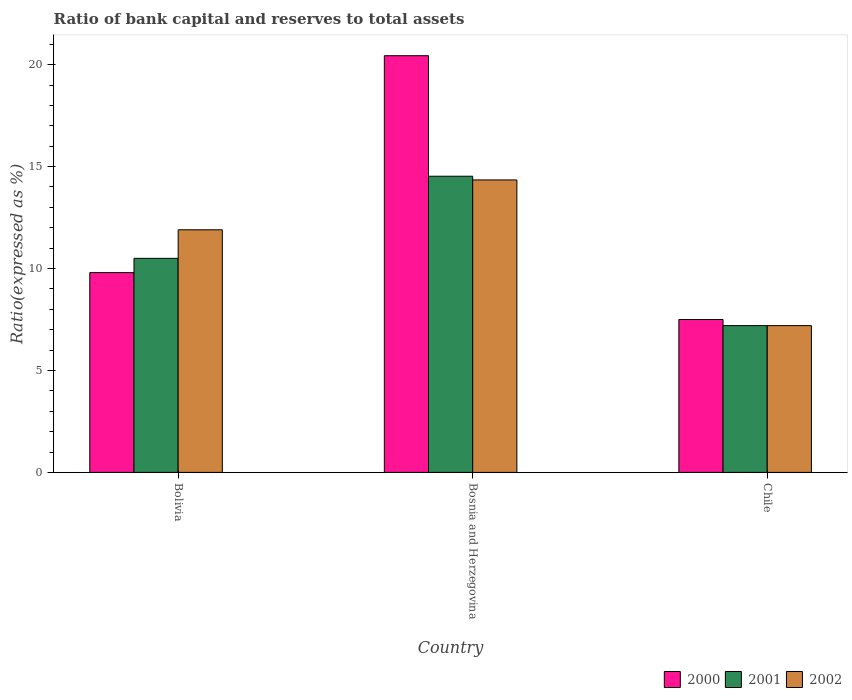How many different coloured bars are there?
Provide a succinct answer. 3. Are the number of bars on each tick of the X-axis equal?
Your answer should be compact. Yes. How many bars are there on the 3rd tick from the right?
Offer a very short reply. 3. What is the label of the 3rd group of bars from the left?
Your answer should be very brief. Chile. In how many cases, is the number of bars for a given country not equal to the number of legend labels?
Ensure brevity in your answer.  0. What is the ratio of bank capital and reserves to total assets in 2000 in Chile?
Your response must be concise. 7.5. Across all countries, what is the maximum ratio of bank capital and reserves to total assets in 2002?
Your answer should be compact. 14.35. Across all countries, what is the minimum ratio of bank capital and reserves to total assets in 2001?
Your answer should be very brief. 7.2. In which country was the ratio of bank capital and reserves to total assets in 2001 maximum?
Your answer should be compact. Bosnia and Herzegovina. What is the total ratio of bank capital and reserves to total assets in 2001 in the graph?
Ensure brevity in your answer.  32.23. What is the difference between the ratio of bank capital and reserves to total assets in 2000 in Bosnia and Herzegovina and that in Chile?
Ensure brevity in your answer.  12.94. What is the average ratio of bank capital and reserves to total assets in 2000 per country?
Ensure brevity in your answer.  12.58. What is the difference between the ratio of bank capital and reserves to total assets of/in 2002 and ratio of bank capital and reserves to total assets of/in 2001 in Chile?
Provide a succinct answer. 0. What is the ratio of the ratio of bank capital and reserves to total assets in 2000 in Bosnia and Herzegovina to that in Chile?
Offer a terse response. 2.73. What is the difference between the highest and the second highest ratio of bank capital and reserves to total assets in 2001?
Give a very brief answer. -4.03. What is the difference between the highest and the lowest ratio of bank capital and reserves to total assets in 2001?
Make the answer very short. 7.33. In how many countries, is the ratio of bank capital and reserves to total assets in 2001 greater than the average ratio of bank capital and reserves to total assets in 2001 taken over all countries?
Ensure brevity in your answer.  1. Is the sum of the ratio of bank capital and reserves to total assets in 2000 in Bolivia and Chile greater than the maximum ratio of bank capital and reserves to total assets in 2001 across all countries?
Offer a very short reply. Yes. Is it the case that in every country, the sum of the ratio of bank capital and reserves to total assets in 2000 and ratio of bank capital and reserves to total assets in 2002 is greater than the ratio of bank capital and reserves to total assets in 2001?
Your answer should be compact. Yes. Does the graph contain any zero values?
Provide a succinct answer. No. Where does the legend appear in the graph?
Provide a short and direct response. Bottom right. What is the title of the graph?
Provide a short and direct response. Ratio of bank capital and reserves to total assets. What is the label or title of the X-axis?
Provide a short and direct response. Country. What is the label or title of the Y-axis?
Give a very brief answer. Ratio(expressed as %). What is the Ratio(expressed as %) of 2001 in Bolivia?
Provide a succinct answer. 10.5. What is the Ratio(expressed as %) in 2002 in Bolivia?
Provide a short and direct response. 11.9. What is the Ratio(expressed as %) of 2000 in Bosnia and Herzegovina?
Offer a very short reply. 20.44. What is the Ratio(expressed as %) of 2001 in Bosnia and Herzegovina?
Ensure brevity in your answer.  14.53. What is the Ratio(expressed as %) in 2002 in Bosnia and Herzegovina?
Keep it short and to the point. 14.35. Across all countries, what is the maximum Ratio(expressed as %) of 2000?
Your response must be concise. 20.44. Across all countries, what is the maximum Ratio(expressed as %) in 2001?
Keep it short and to the point. 14.53. Across all countries, what is the maximum Ratio(expressed as %) of 2002?
Give a very brief answer. 14.35. Across all countries, what is the minimum Ratio(expressed as %) of 2000?
Keep it short and to the point. 7.5. Across all countries, what is the minimum Ratio(expressed as %) in 2001?
Your answer should be very brief. 7.2. Across all countries, what is the minimum Ratio(expressed as %) in 2002?
Provide a short and direct response. 7.2. What is the total Ratio(expressed as %) of 2000 in the graph?
Ensure brevity in your answer.  37.74. What is the total Ratio(expressed as %) of 2001 in the graph?
Ensure brevity in your answer.  32.23. What is the total Ratio(expressed as %) of 2002 in the graph?
Provide a succinct answer. 33.45. What is the difference between the Ratio(expressed as %) of 2000 in Bolivia and that in Bosnia and Herzegovina?
Give a very brief answer. -10.64. What is the difference between the Ratio(expressed as %) in 2001 in Bolivia and that in Bosnia and Herzegovina?
Your answer should be compact. -4.03. What is the difference between the Ratio(expressed as %) in 2002 in Bolivia and that in Bosnia and Herzegovina?
Give a very brief answer. -2.45. What is the difference between the Ratio(expressed as %) in 2002 in Bolivia and that in Chile?
Offer a terse response. 4.7. What is the difference between the Ratio(expressed as %) in 2000 in Bosnia and Herzegovina and that in Chile?
Offer a very short reply. 12.94. What is the difference between the Ratio(expressed as %) of 2001 in Bosnia and Herzegovina and that in Chile?
Your answer should be very brief. 7.33. What is the difference between the Ratio(expressed as %) of 2002 in Bosnia and Herzegovina and that in Chile?
Give a very brief answer. 7.15. What is the difference between the Ratio(expressed as %) in 2000 in Bolivia and the Ratio(expressed as %) in 2001 in Bosnia and Herzegovina?
Provide a succinct answer. -4.73. What is the difference between the Ratio(expressed as %) in 2000 in Bolivia and the Ratio(expressed as %) in 2002 in Bosnia and Herzegovina?
Offer a very short reply. -4.55. What is the difference between the Ratio(expressed as %) in 2001 in Bolivia and the Ratio(expressed as %) in 2002 in Bosnia and Herzegovina?
Your response must be concise. -3.85. What is the difference between the Ratio(expressed as %) in 2000 in Bosnia and Herzegovina and the Ratio(expressed as %) in 2001 in Chile?
Make the answer very short. 13.24. What is the difference between the Ratio(expressed as %) in 2000 in Bosnia and Herzegovina and the Ratio(expressed as %) in 2002 in Chile?
Keep it short and to the point. 13.24. What is the difference between the Ratio(expressed as %) of 2001 in Bosnia and Herzegovina and the Ratio(expressed as %) of 2002 in Chile?
Your answer should be compact. 7.33. What is the average Ratio(expressed as %) of 2000 per country?
Your answer should be compact. 12.58. What is the average Ratio(expressed as %) in 2001 per country?
Provide a short and direct response. 10.74. What is the average Ratio(expressed as %) in 2002 per country?
Give a very brief answer. 11.15. What is the difference between the Ratio(expressed as %) in 2000 and Ratio(expressed as %) in 2001 in Bosnia and Herzegovina?
Offer a terse response. 5.91. What is the difference between the Ratio(expressed as %) in 2000 and Ratio(expressed as %) in 2002 in Bosnia and Herzegovina?
Your response must be concise. 6.09. What is the difference between the Ratio(expressed as %) in 2001 and Ratio(expressed as %) in 2002 in Bosnia and Herzegovina?
Offer a very short reply. 0.18. What is the difference between the Ratio(expressed as %) in 2000 and Ratio(expressed as %) in 2001 in Chile?
Provide a short and direct response. 0.3. What is the difference between the Ratio(expressed as %) in 2001 and Ratio(expressed as %) in 2002 in Chile?
Offer a very short reply. 0. What is the ratio of the Ratio(expressed as %) of 2000 in Bolivia to that in Bosnia and Herzegovina?
Provide a succinct answer. 0.48. What is the ratio of the Ratio(expressed as %) of 2001 in Bolivia to that in Bosnia and Herzegovina?
Keep it short and to the point. 0.72. What is the ratio of the Ratio(expressed as %) in 2002 in Bolivia to that in Bosnia and Herzegovina?
Your answer should be very brief. 0.83. What is the ratio of the Ratio(expressed as %) of 2000 in Bolivia to that in Chile?
Your answer should be very brief. 1.31. What is the ratio of the Ratio(expressed as %) of 2001 in Bolivia to that in Chile?
Provide a succinct answer. 1.46. What is the ratio of the Ratio(expressed as %) of 2002 in Bolivia to that in Chile?
Provide a succinct answer. 1.65. What is the ratio of the Ratio(expressed as %) in 2000 in Bosnia and Herzegovina to that in Chile?
Ensure brevity in your answer.  2.73. What is the ratio of the Ratio(expressed as %) in 2001 in Bosnia and Herzegovina to that in Chile?
Ensure brevity in your answer.  2.02. What is the ratio of the Ratio(expressed as %) of 2002 in Bosnia and Herzegovina to that in Chile?
Provide a succinct answer. 1.99. What is the difference between the highest and the second highest Ratio(expressed as %) in 2000?
Provide a short and direct response. 10.64. What is the difference between the highest and the second highest Ratio(expressed as %) in 2001?
Give a very brief answer. 4.03. What is the difference between the highest and the second highest Ratio(expressed as %) in 2002?
Ensure brevity in your answer.  2.45. What is the difference between the highest and the lowest Ratio(expressed as %) of 2000?
Offer a very short reply. 12.94. What is the difference between the highest and the lowest Ratio(expressed as %) in 2001?
Keep it short and to the point. 7.33. What is the difference between the highest and the lowest Ratio(expressed as %) of 2002?
Your answer should be compact. 7.15. 